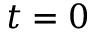Convert formula to latex. <formula><loc_0><loc_0><loc_500><loc_500>t = 0</formula> 